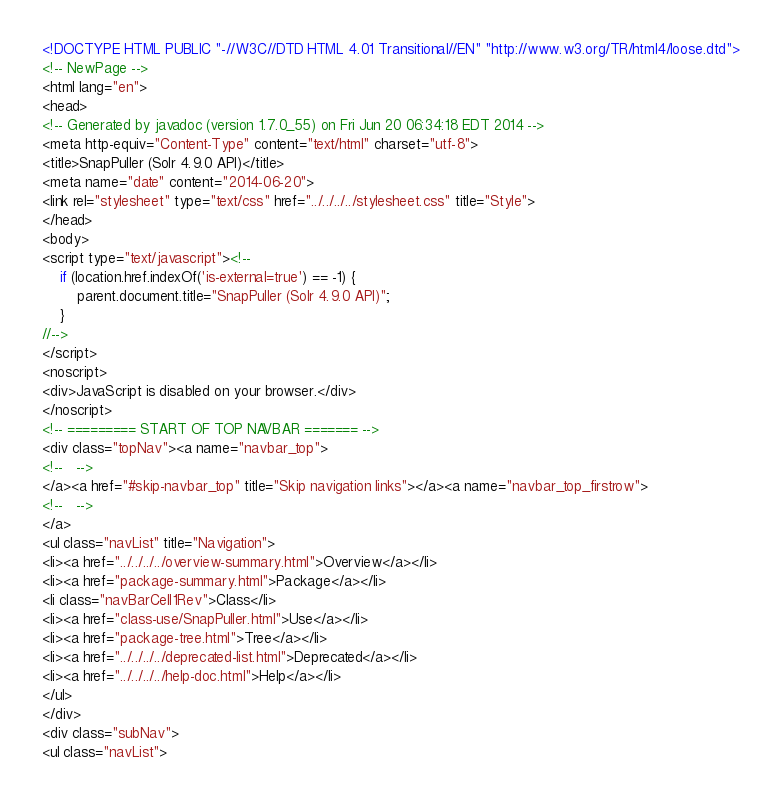Convert code to text. <code><loc_0><loc_0><loc_500><loc_500><_HTML_><!DOCTYPE HTML PUBLIC "-//W3C//DTD HTML 4.01 Transitional//EN" "http://www.w3.org/TR/html4/loose.dtd">
<!-- NewPage -->
<html lang="en">
<head>
<!-- Generated by javadoc (version 1.7.0_55) on Fri Jun 20 06:34:18 EDT 2014 -->
<meta http-equiv="Content-Type" content="text/html" charset="utf-8">
<title>SnapPuller (Solr 4.9.0 API)</title>
<meta name="date" content="2014-06-20">
<link rel="stylesheet" type="text/css" href="../../../../stylesheet.css" title="Style">
</head>
<body>
<script type="text/javascript"><!--
    if (location.href.indexOf('is-external=true') == -1) {
        parent.document.title="SnapPuller (Solr 4.9.0 API)";
    }
//-->
</script>
<noscript>
<div>JavaScript is disabled on your browser.</div>
</noscript>
<!-- ========= START OF TOP NAVBAR ======= -->
<div class="topNav"><a name="navbar_top">
<!--   -->
</a><a href="#skip-navbar_top" title="Skip navigation links"></a><a name="navbar_top_firstrow">
<!--   -->
</a>
<ul class="navList" title="Navigation">
<li><a href="../../../../overview-summary.html">Overview</a></li>
<li><a href="package-summary.html">Package</a></li>
<li class="navBarCell1Rev">Class</li>
<li><a href="class-use/SnapPuller.html">Use</a></li>
<li><a href="package-tree.html">Tree</a></li>
<li><a href="../../../../deprecated-list.html">Deprecated</a></li>
<li><a href="../../../../help-doc.html">Help</a></li>
</ul>
</div>
<div class="subNav">
<ul class="navList"></code> 